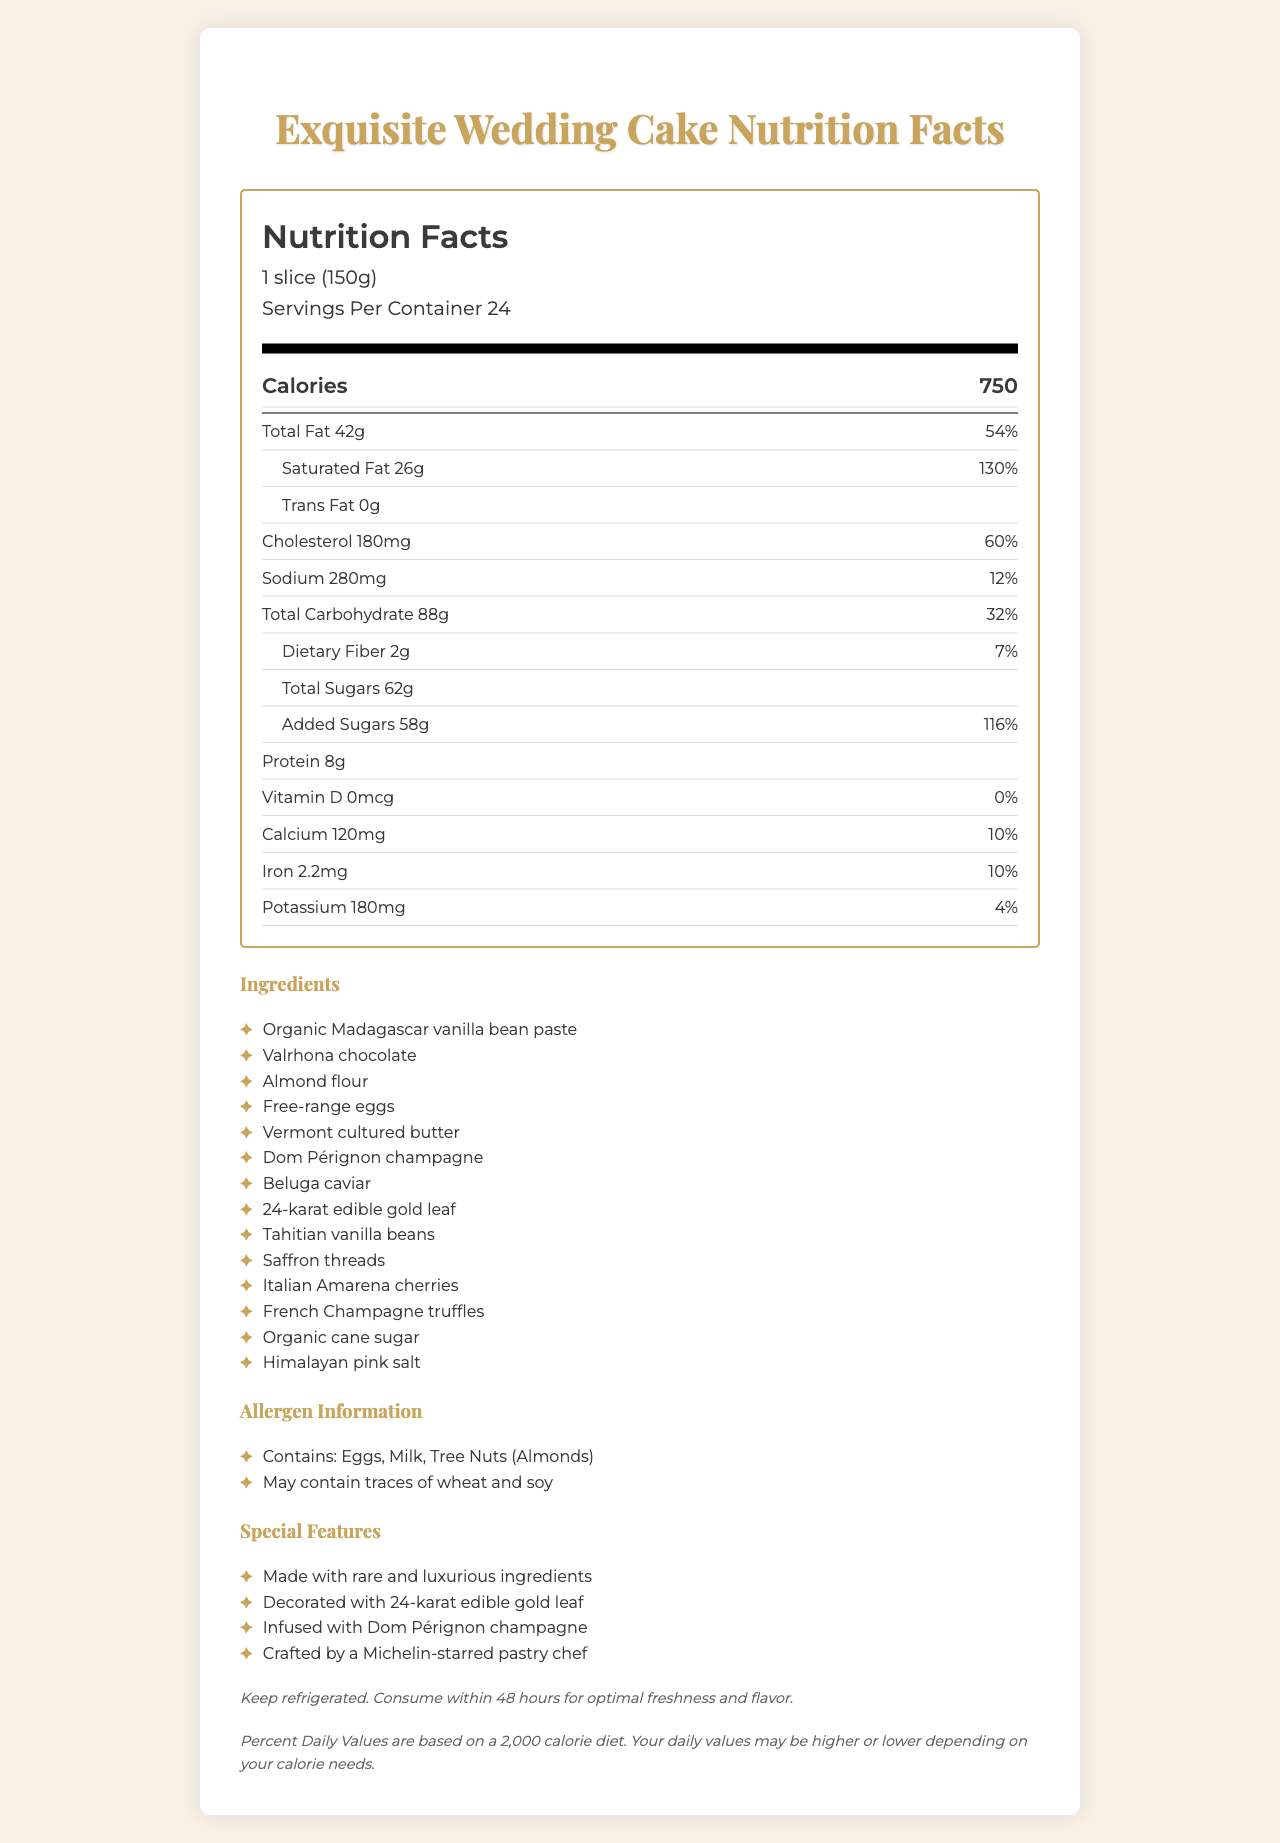what is the serving size? The serving size is clearly mentioned at the top of the Nutrition Facts label as 1 slice (150g).
Answer: 1 slice (150g) how many servings are in the container? The document mentions that there are 24 servings per container.
Answer: 24 how many calories are in one serving of the cake? The document lists that one serving of the cake contains 750 calories.
Answer: 750 what is the total fat content per serving? The total fat content per serving is stated as 42g.
Answer: 42g what is the daily value percentage for cholesterol per serving? The daily value percentage for cholesterol per serving is listed as 60%.
Answer: 60% how many grams of dietary fiber are in one serving? The dietary fiber content per serving is listed as 2g.
Answer: 2g what types of sugar are listed in the nutrition facts? A. Glucose B. Fructose C. Total Sugars D. Added Sugars E. Honey The document mentions Total Sugars and Added Sugars.
Answer: C, D which rare and luxurious ingredient is infused into the wedding cake? A. Saffron threads B. Tahitian vanilla beans C. Dom Pérignon champagne D. 24-karat edible gold leaf The document lists Dom Pérignon champagne as a luxurious ingredient that is infused into the wedding cake.
Answer: C. Dom Pérignon champagne is this cake suitable for someone with a tree nut allergy? The allergen information indicates that the cake contains tree nuts (Almonds).
Answer: No does the cake contain any trans fat? The document states that the cake contains 0g of trans fat.
Answer: No summarize the special features of this wedding cake. The document lists special features like using rare ingredients, gold leaf decoration, champagne infusion, and Michelin-star chef craftsmanship, indicating the cake’s exclusivity and luxury.
Answer: The wedding cake is crafted with rare and luxurious ingredients, decorated with 24-karat edible gold leaf, infused with Dom Pérignon champagne, and created by a Michelin-starred pastry chef. what are the storage instructions for this cake? The storage instructions indicate that the cake should be kept refrigerated and consumed within 48 hours to maintain freshness and flavor.
Answer: Keep refrigerated. Consume within 48 hours for optimal freshness and flavor. can the daily values listed on the nutrition label be applied to everyone's diet? The disclaimer at the end mentions that the Percent Daily Values are based on a 2,000 calorie diet and may vary depending on individual calorie needs.
Answer: No what is the protein content per slice? Each serving of the cake contains 8g of protein.
Answer: 8g which of the following ingredients provides the cake with its vanilla flavor? Both "Organic Madagascar vanilla bean paste" and "Tahitian vanilla beans" are listed as ingredients for flavoring the cake.
Answer: Both A and D how many grams of total sugars does the cake contain per serving? The total sugars content per serving is listed as 62g.
Answer: 62g what rare ingredient is not mentioned in the nutrition document? Since the question mentions a rare ingredient not listed, which isn't available in the document, the answer cannot be determined based on the visual information provided.
Answer: Not enough information 